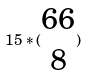Convert formula to latex. <formula><loc_0><loc_0><loc_500><loc_500>1 5 * ( \begin{matrix} 6 6 \\ 8 \end{matrix} )</formula> 